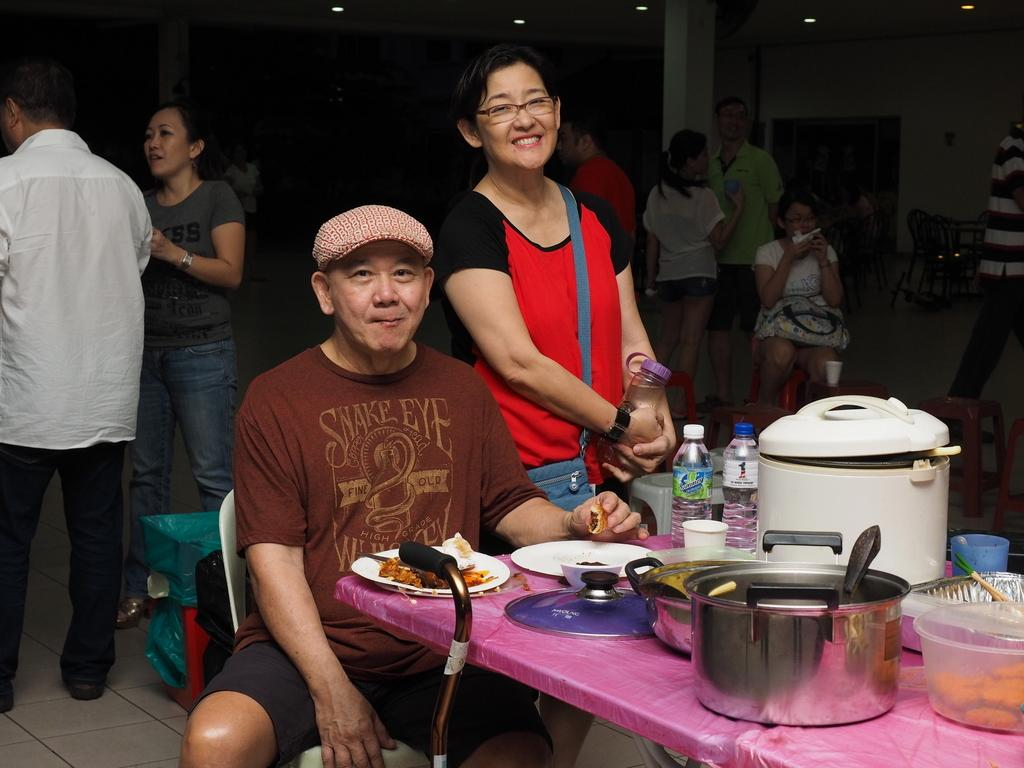What is the man in the image doing? The man is sitting on a chair in the image. What objects are on the table in the image? There are plates, utensils, and bottles on the table in the image. What type of celery is being used as a veil in the image? There is no celery or veil present in the image. 